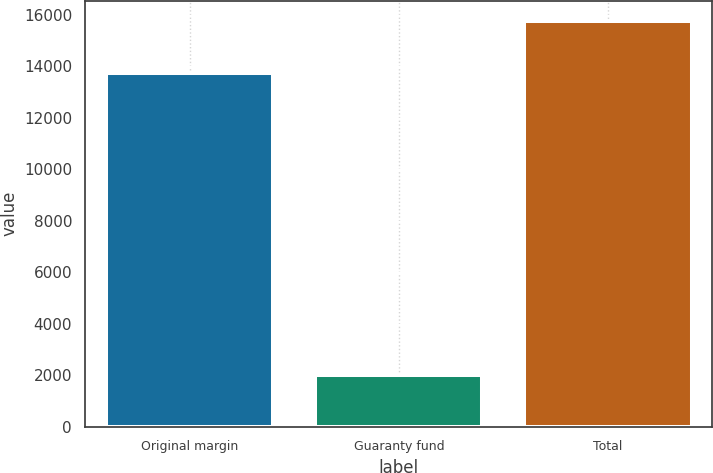Convert chart. <chart><loc_0><loc_0><loc_500><loc_500><bar_chart><fcel>Original margin<fcel>Guaranty fund<fcel>Total<nl><fcel>13750<fcel>2011<fcel>15761<nl></chart> 